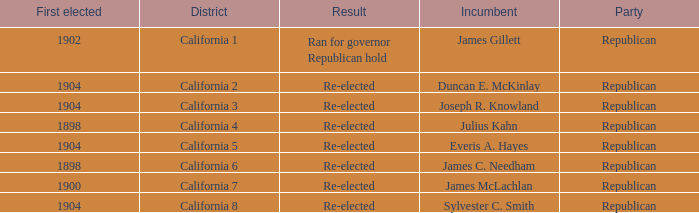Which Incumbent has a District of California 5? Everis A. Hayes. 